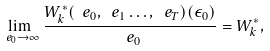Convert formula to latex. <formula><loc_0><loc_0><loc_500><loc_500>\lim _ { \ e _ { 0 } \to \infty } \frac { W ^ { * } _ { k } ( \ e _ { 0 } , \ e _ { 1 } \dots , \ e _ { T } ) ( \epsilon _ { 0 } ) } { \ e _ { 0 } } = W ^ { * } _ { k } ,</formula> 